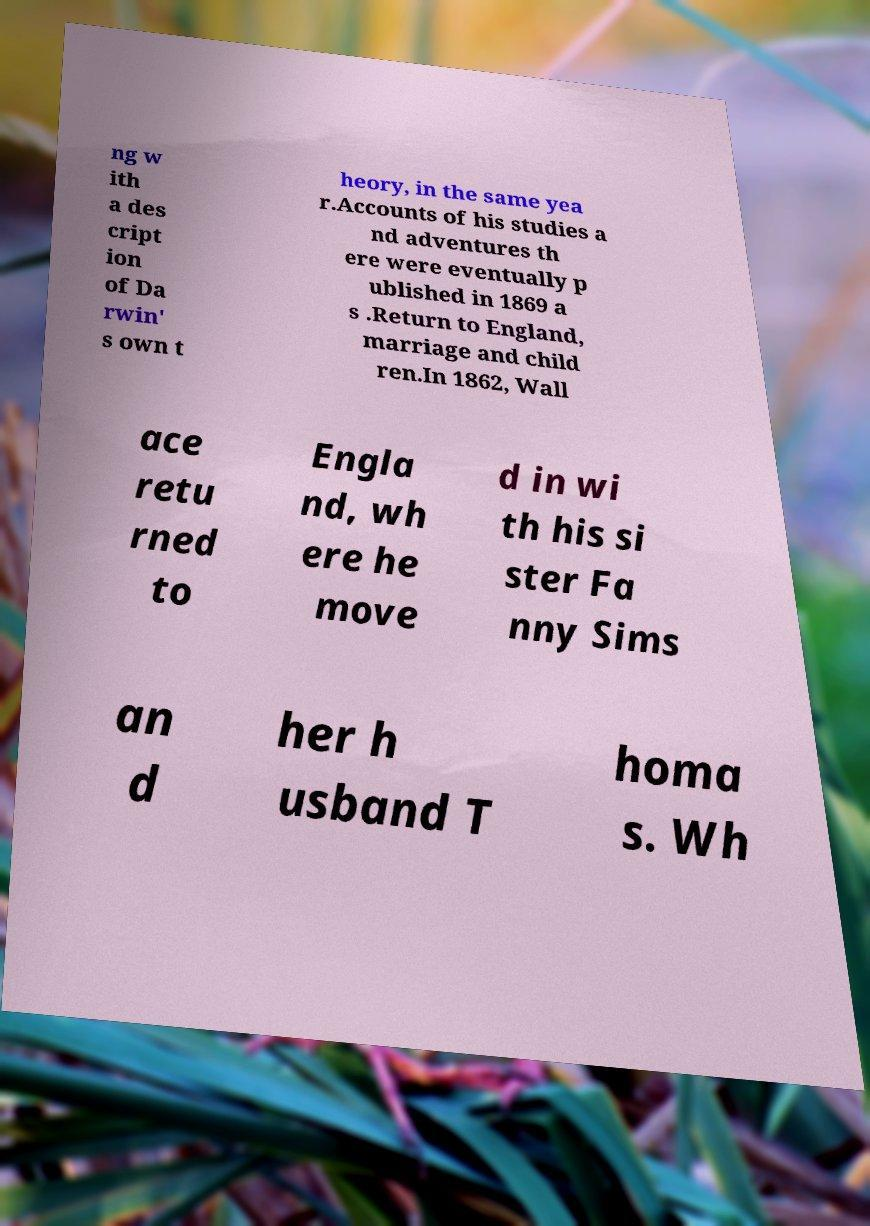Please read and relay the text visible in this image. What does it say? ng w ith a des cript ion of Da rwin' s own t heory, in the same yea r.Accounts of his studies a nd adventures th ere were eventually p ublished in 1869 a s .Return to England, marriage and child ren.In 1862, Wall ace retu rned to Engla nd, wh ere he move d in wi th his si ster Fa nny Sims an d her h usband T homa s. Wh 